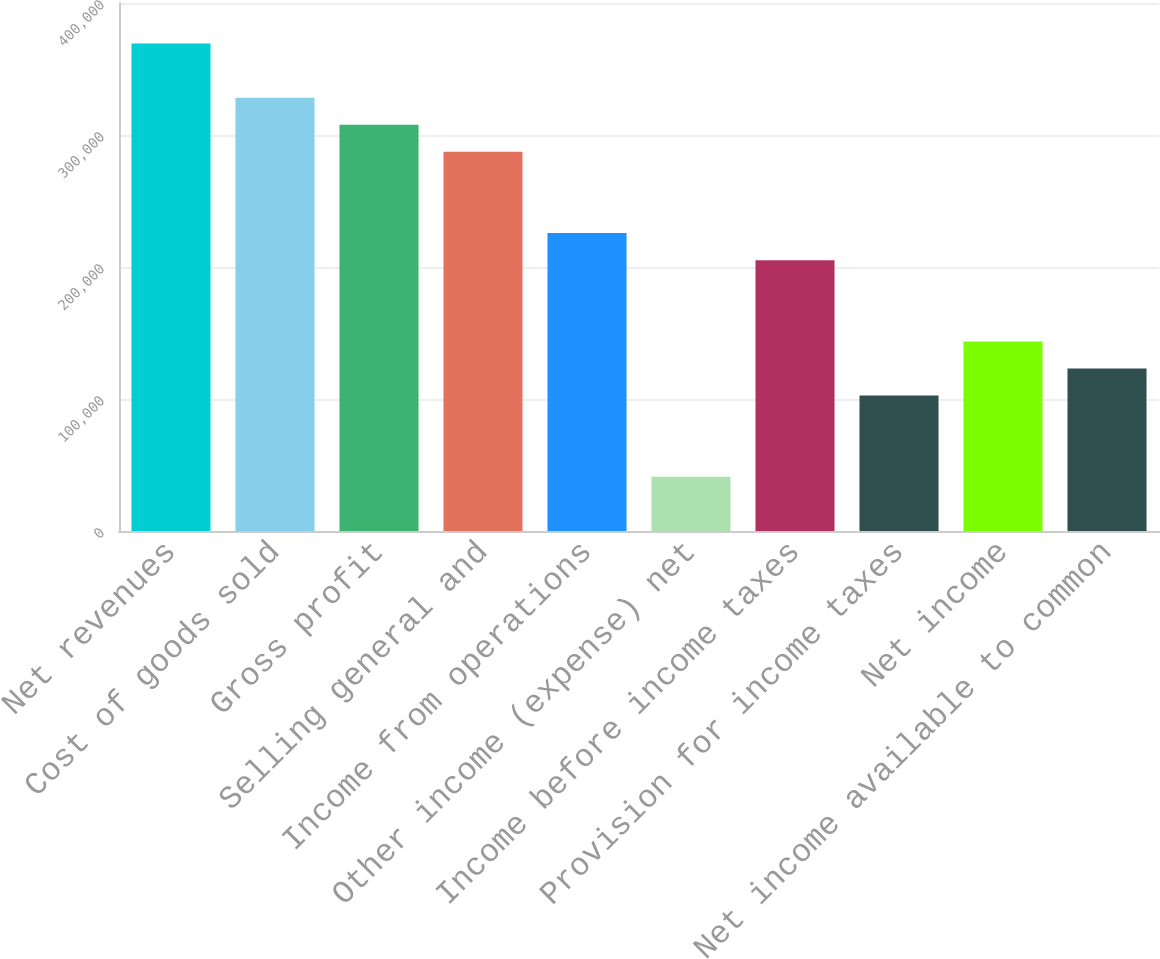Convert chart to OTSL. <chart><loc_0><loc_0><loc_500><loc_500><bar_chart><fcel>Net revenues<fcel>Cost of goods sold<fcel>Gross profit<fcel>Selling general and<fcel>Income from operations<fcel>Other income (expense) net<fcel>Income before income taxes<fcel>Provision for income taxes<fcel>Net income<fcel>Net income available to common<nl><fcel>369325<fcel>328289<fcel>307771<fcel>287253<fcel>225699<fcel>41036.5<fcel>205181<fcel>102591<fcel>143627<fcel>123109<nl></chart> 